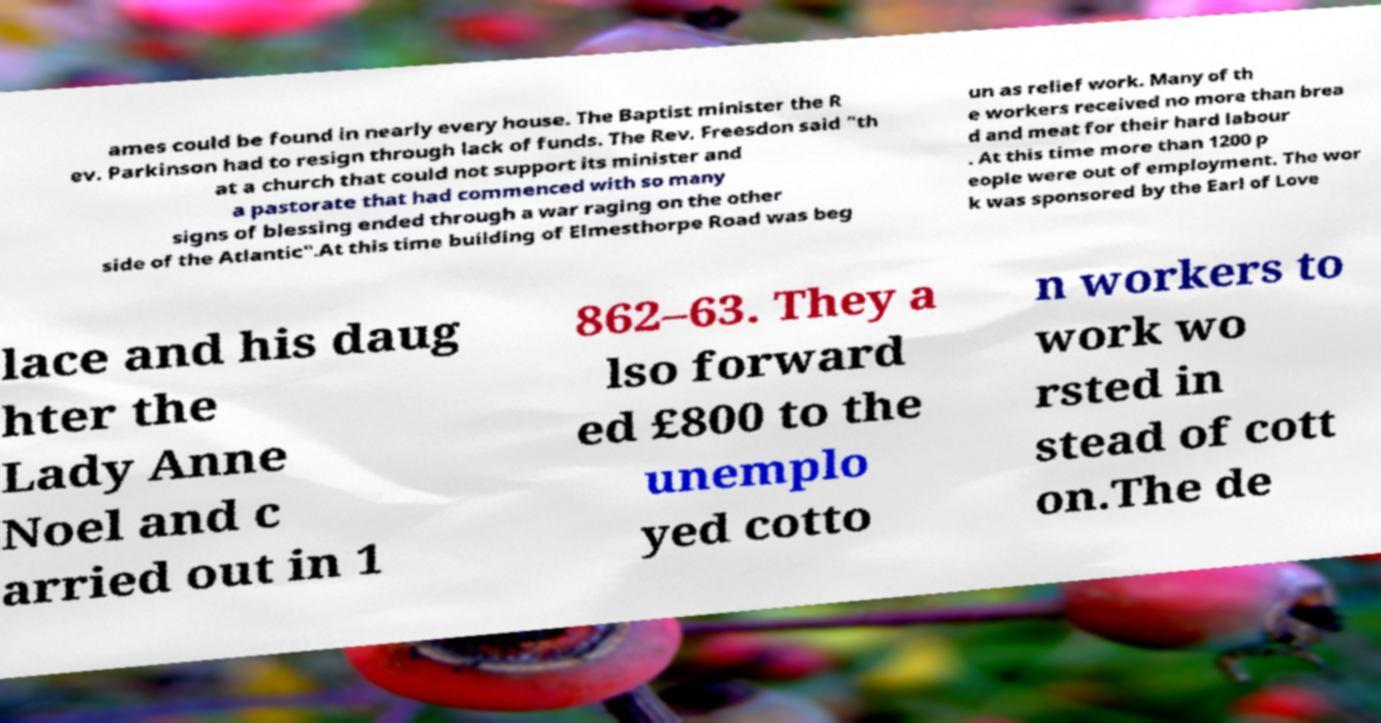Can you read and provide the text displayed in the image?This photo seems to have some interesting text. Can you extract and type it out for me? ames could be found in nearly every house. The Baptist minister the R ev. Parkinson had to resign through lack of funds. The Rev. Freesdon said "th at a church that could not support its minister and a pastorate that had commenced with so many signs of blessing ended through a war raging on the other side of the Atlantic".At this time building of Elmesthorpe Road was beg un as relief work. Many of th e workers received no more than brea d and meat for their hard labour . At this time more than 1200 p eople were out of employment. The wor k was sponsored by the Earl of Love lace and his daug hter the Lady Anne Noel and c arried out in 1 862–63. They a lso forward ed £800 to the unemplo yed cotto n workers to work wo rsted in stead of cott on.The de 